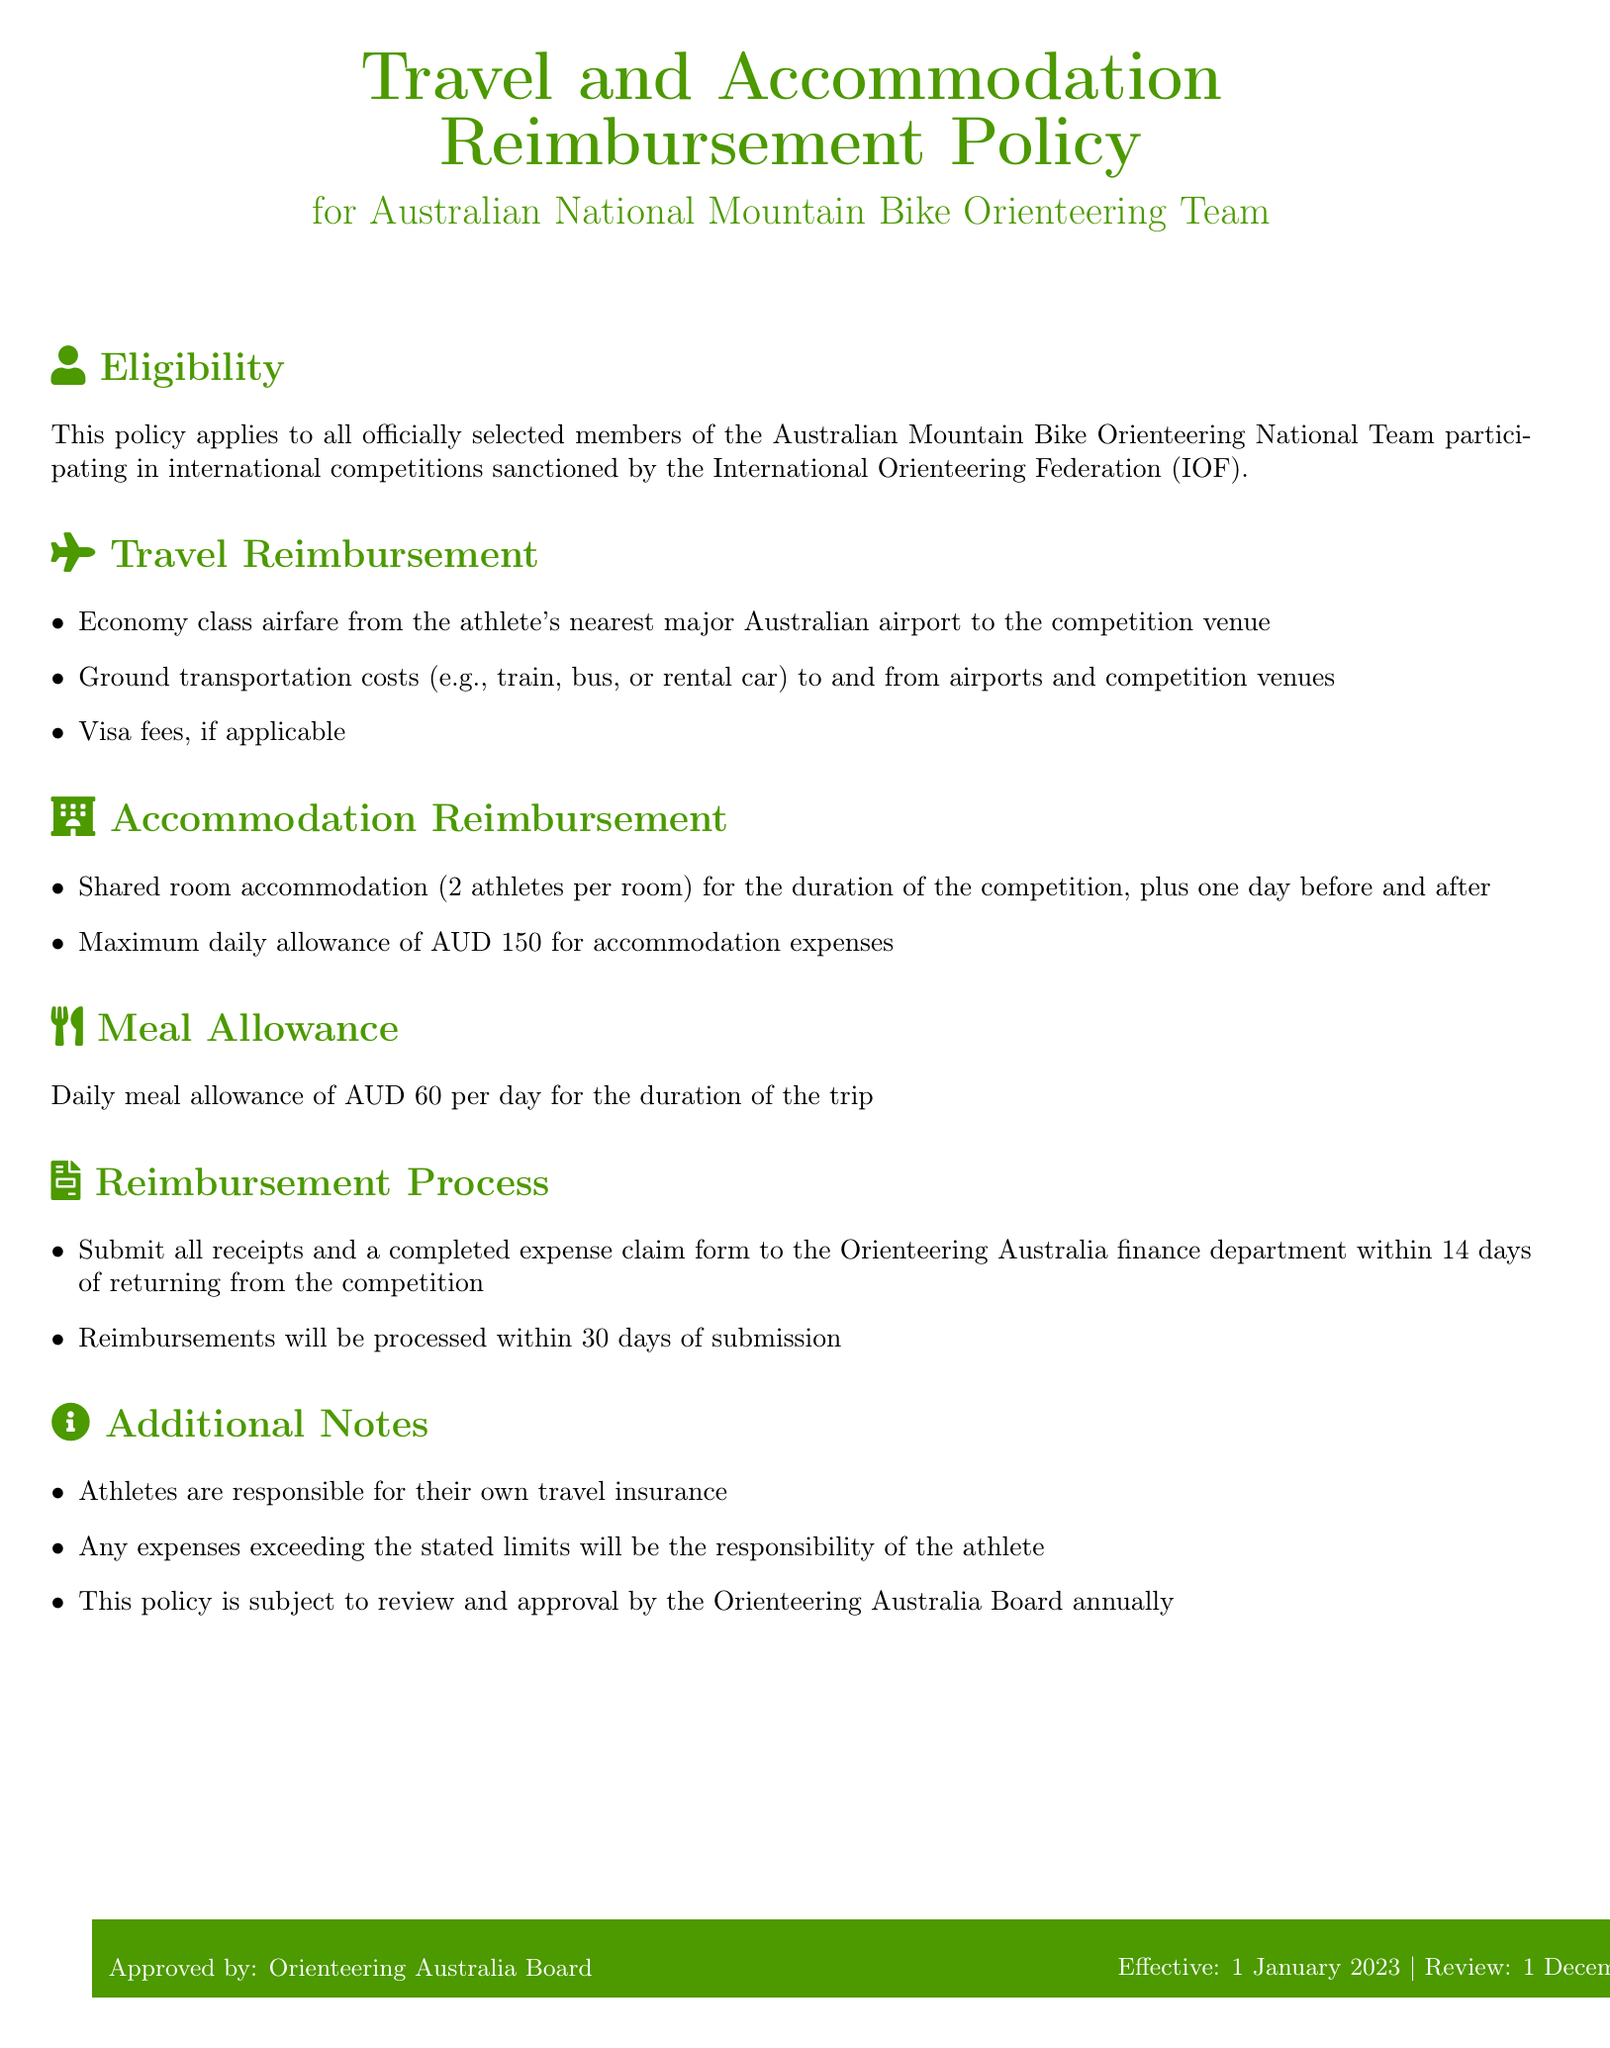What is the maximum daily allowance for accommodation expenses? The policy states that the maximum daily allowance for accommodation expenses is AUD 150.
Answer: AUD 150 What is the daily meal allowance for athletes? The policy specifies a daily meal allowance of AUD 60 per day for the duration of the trip.
Answer: AUD 60 How many days of accommodation are covered? The policy covers shared room accommodation for the duration of the competition, plus one day before and after, totaling three days.
Answer: Three days Who approves this policy? The policy document states that it is approved by the Orienteering Australia Board.
Answer: Orienteering Australia Board What is the reimbursement processing time? According to the document, reimbursements will be processed within 30 days of submission.
Answer: 30 days What types of transportation costs are covered? The document mentions that ground transportation costs such as train, bus, or rental car to and from airports and competition venues are covered.
Answer: Ground transportation costs When is the effective date of this policy? The effective date of the policy is stated as January 1, 2023.
Answer: January 1, 2023 What is required for the reimbursement process? Athletes must submit all receipts and a completed expense claim form to the Orienteering Australia finance department.
Answer: Receipts and expense claim form 